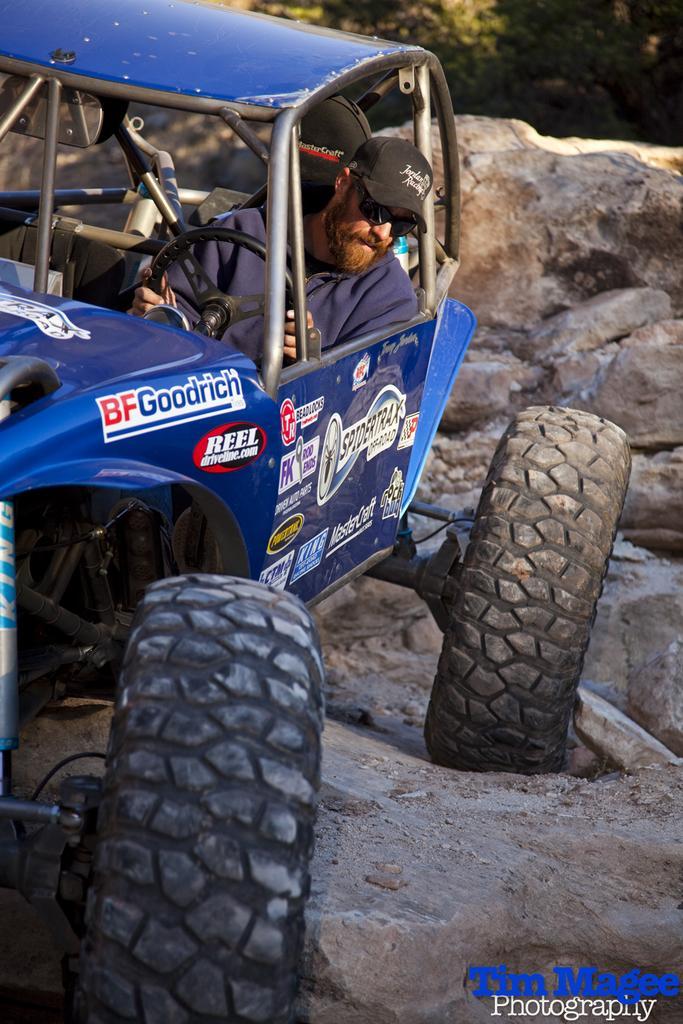Describe this image in one or two sentences. He is sitting on a motorcycle. He's holding a steering. He's wearing a cap. We can see in the background there is a stone and trees. 